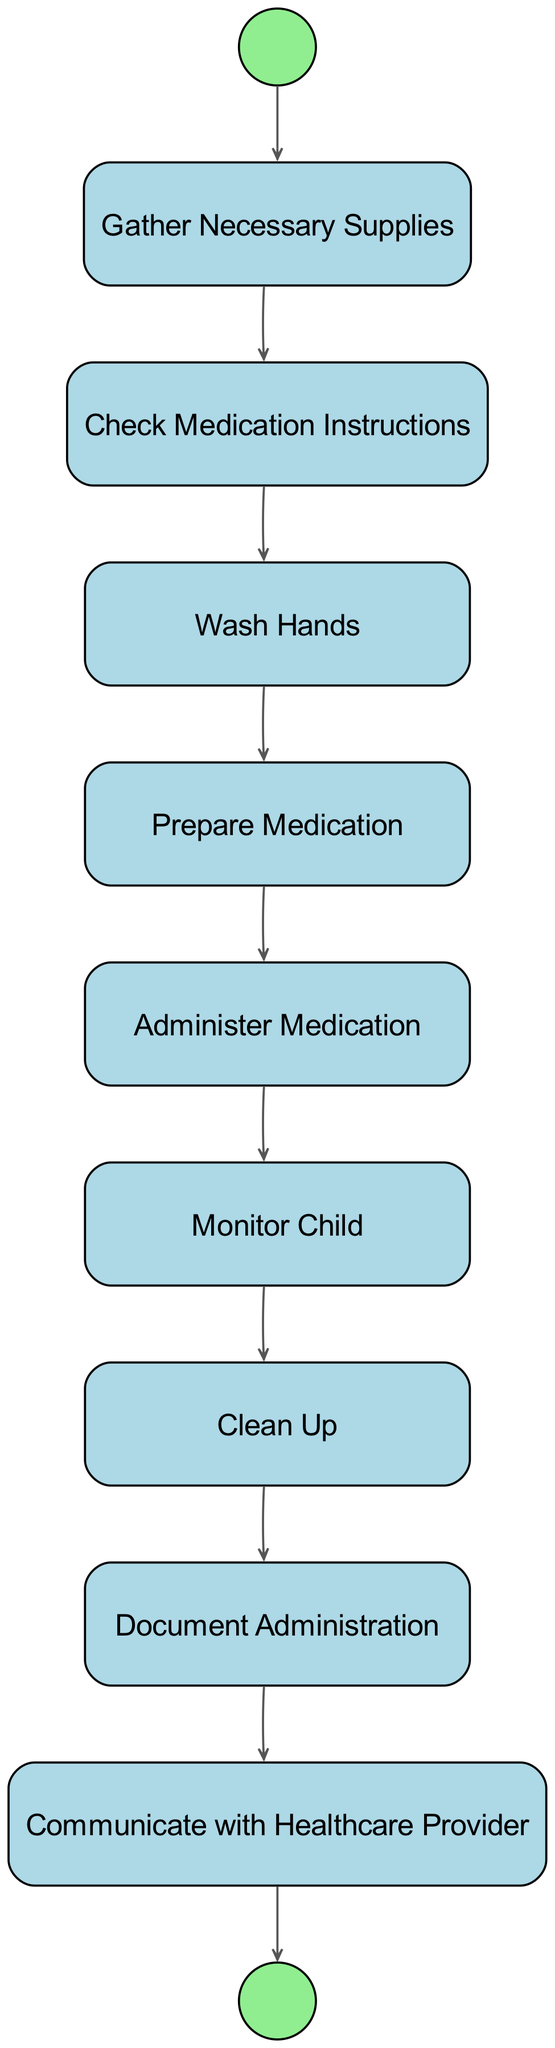What is the starting activity in the diagram? The starting activity is indicated as the first node connected to the start event. According to the diagram data, "Gather Necessary Supplies" is first in the activities list and is identified as the start event.
Answer: Gather Necessary Supplies How many activities are listed in the diagram? Counting the activities provided in the data, there are eight distinct activities mentioned under "activities." Each activity represents a step in the process.
Answer: 8 What is the last activity before the end event? The last activity before the end event is the one that precedes the transition to the end event in the flow. According to the transitions, "Document Administration" is the final activity linked before communicating with the healthcare provider.
Answer: Document Administration Which activity follows "Wash Hands"? The transition from "Wash Hands" leads directly to "Prepare Medication," as specified in the transitions list. This order shows the sequence of activities occurring in the medication administration process.
Answer: Prepare Medication How many transitions are present in the diagram? To determine the number of transitions, one can count the connections listed in the "transitions" section. There are eight transitions that indicate the flow between the activities.
Answer: 8 What activity occurs immediately after "Administer Medication"? The activity immediately following "Administer Medication" is "Monitor Child." This is derived from examining the transition that follows the administering of the medication.
Answer: Monitor Child Which activity is the penultimate step before communicating with the healthcare provider? The penultimate step is the activity that comes directly before communicating with the healthcare provider, which, as shown in the transitions, is "Document Administration."
Answer: Document Administration What is the connection between "Clean Up" and "Document Administration"? The connection between "Clean Up" and "Document Administration" shows a direct transition, where "Clean Up" leads straight into "Document Administration" as the next step in the process.
Answer: Direct transition 